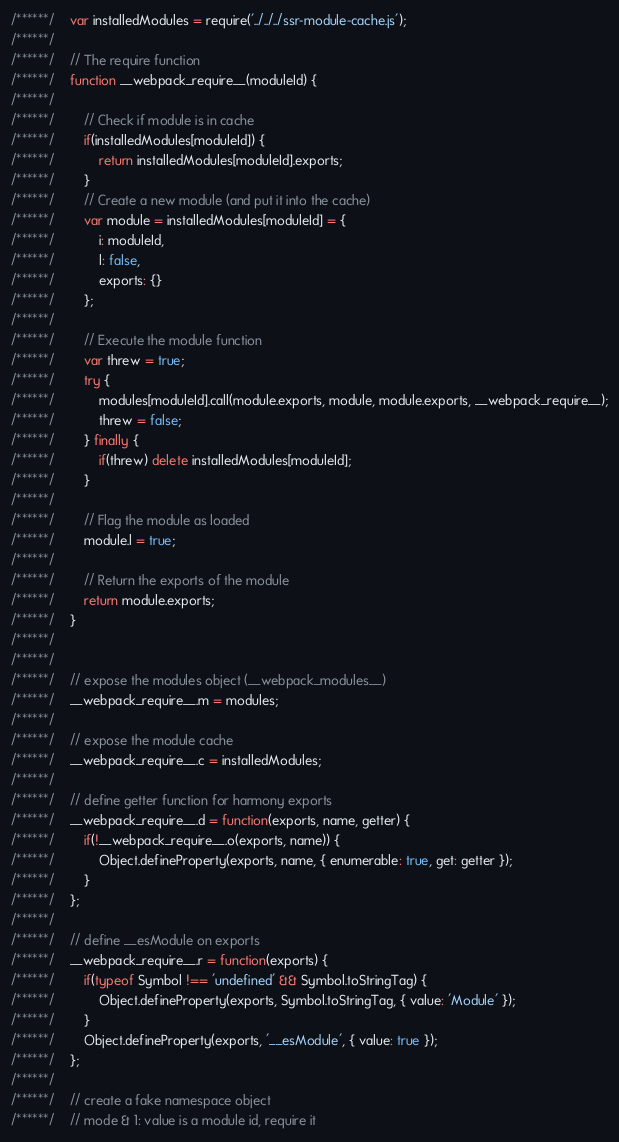<code> <loc_0><loc_0><loc_500><loc_500><_JavaScript_>/******/ 	var installedModules = require('../../../ssr-module-cache.js');
/******/
/******/ 	// The require function
/******/ 	function __webpack_require__(moduleId) {
/******/
/******/ 		// Check if module is in cache
/******/ 		if(installedModules[moduleId]) {
/******/ 			return installedModules[moduleId].exports;
/******/ 		}
/******/ 		// Create a new module (and put it into the cache)
/******/ 		var module = installedModules[moduleId] = {
/******/ 			i: moduleId,
/******/ 			l: false,
/******/ 			exports: {}
/******/ 		};
/******/
/******/ 		// Execute the module function
/******/ 		var threw = true;
/******/ 		try {
/******/ 			modules[moduleId].call(module.exports, module, module.exports, __webpack_require__);
/******/ 			threw = false;
/******/ 		} finally {
/******/ 			if(threw) delete installedModules[moduleId];
/******/ 		}
/******/
/******/ 		// Flag the module as loaded
/******/ 		module.l = true;
/******/
/******/ 		// Return the exports of the module
/******/ 		return module.exports;
/******/ 	}
/******/
/******/
/******/ 	// expose the modules object (__webpack_modules__)
/******/ 	__webpack_require__.m = modules;
/******/
/******/ 	// expose the module cache
/******/ 	__webpack_require__.c = installedModules;
/******/
/******/ 	// define getter function for harmony exports
/******/ 	__webpack_require__.d = function(exports, name, getter) {
/******/ 		if(!__webpack_require__.o(exports, name)) {
/******/ 			Object.defineProperty(exports, name, { enumerable: true, get: getter });
/******/ 		}
/******/ 	};
/******/
/******/ 	// define __esModule on exports
/******/ 	__webpack_require__.r = function(exports) {
/******/ 		if(typeof Symbol !== 'undefined' && Symbol.toStringTag) {
/******/ 			Object.defineProperty(exports, Symbol.toStringTag, { value: 'Module' });
/******/ 		}
/******/ 		Object.defineProperty(exports, '__esModule', { value: true });
/******/ 	};
/******/
/******/ 	// create a fake namespace object
/******/ 	// mode & 1: value is a module id, require it</code> 